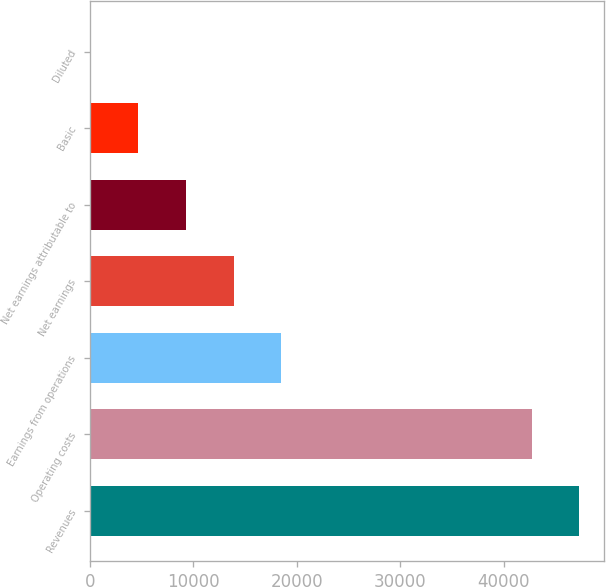Convert chart. <chart><loc_0><loc_0><loc_500><loc_500><bar_chart><fcel>Revenues<fcel>Operating costs<fcel>Earnings from operations<fcel>Net earnings<fcel>Net earnings attributable to<fcel>Basic<fcel>Diluted<nl><fcel>47342.1<fcel>42713<fcel>18518.4<fcel>13889.3<fcel>9260.23<fcel>4631.13<fcel>2.03<nl></chart> 